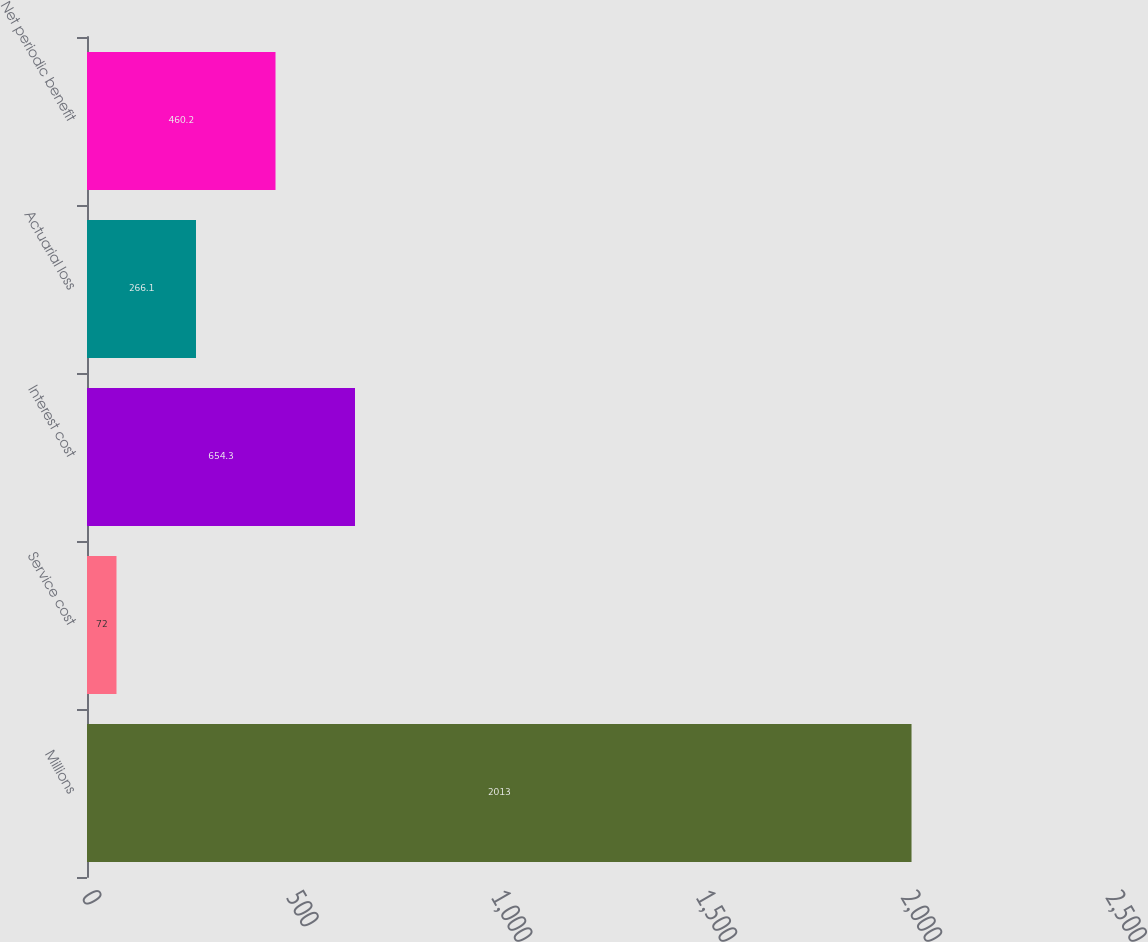Convert chart to OTSL. <chart><loc_0><loc_0><loc_500><loc_500><bar_chart><fcel>Millions<fcel>Service cost<fcel>Interest cost<fcel>Actuarial loss<fcel>Net periodic benefit<nl><fcel>2013<fcel>72<fcel>654.3<fcel>266.1<fcel>460.2<nl></chart> 